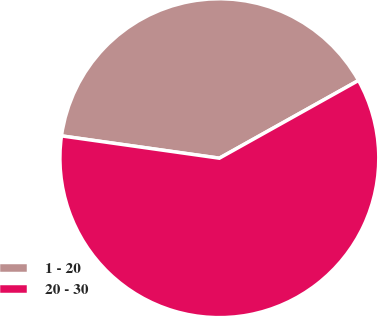Convert chart to OTSL. <chart><loc_0><loc_0><loc_500><loc_500><pie_chart><fcel>1 - 20<fcel>20 - 30<nl><fcel>39.66%<fcel>60.34%<nl></chart> 